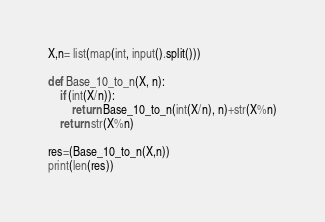Convert code to text. <code><loc_0><loc_0><loc_500><loc_500><_Python_>
X,n= list(map(int, input().split())) 

def Base_10_to_n(X, n):
    if (int(X/n)):
        return Base_10_to_n(int(X/n), n)+str(X%n)
    return str(X%n)

res=(Base_10_to_n(X,n))
print(len(res))</code> 